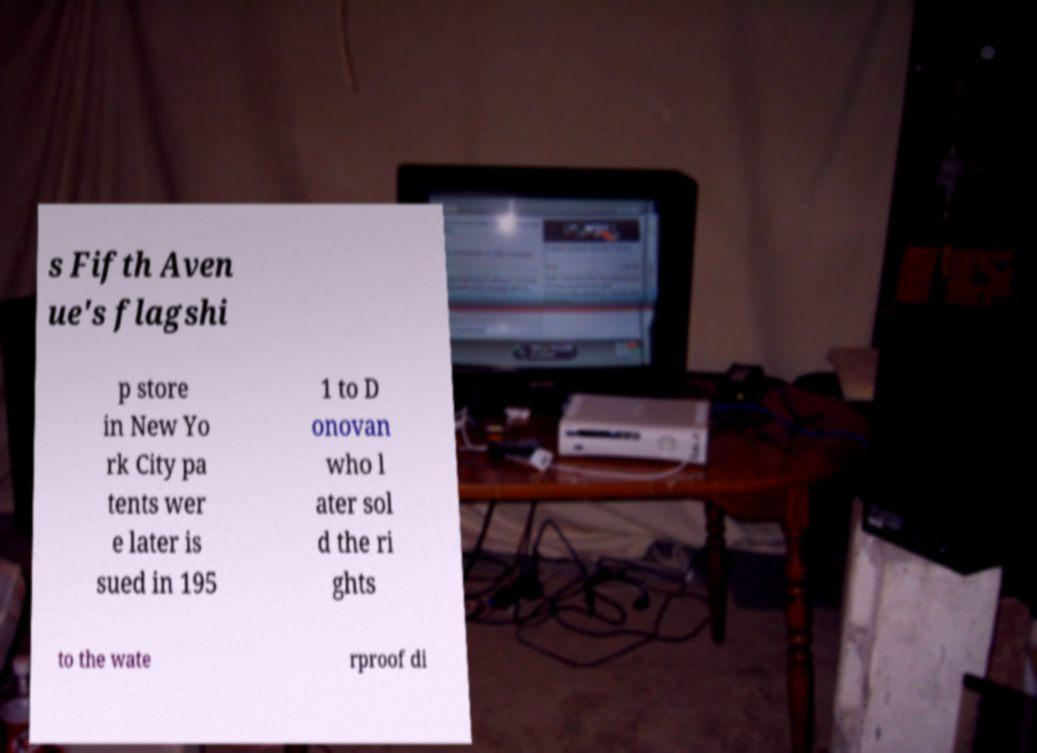For documentation purposes, I need the text within this image transcribed. Could you provide that? s Fifth Aven ue's flagshi p store in New Yo rk City pa tents wer e later is sued in 195 1 to D onovan who l ater sol d the ri ghts to the wate rproof di 